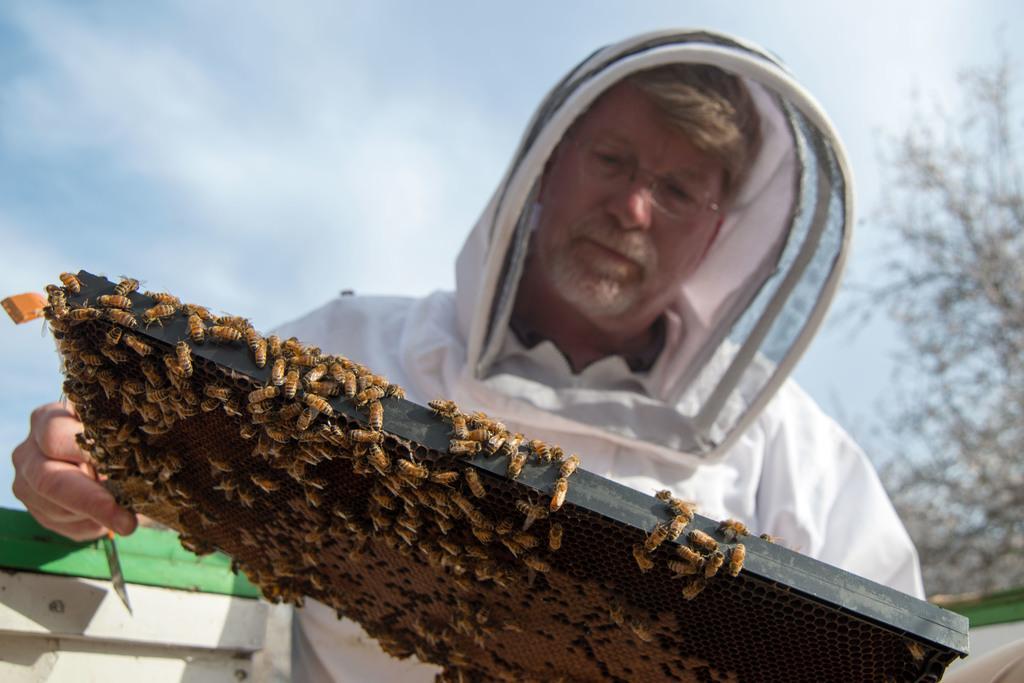Please provide a concise description of this image. In this image there is a man in the center holding a stand which is full of honey bees. In the background there is a tree and the sky is cloudy. 